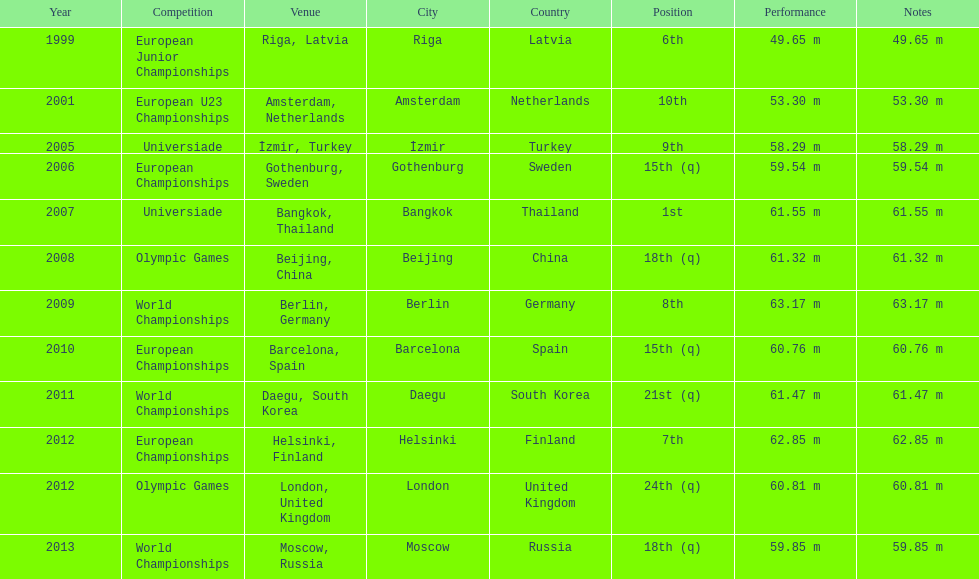What was the last competition he was in before the 2012 olympics? European Championships. 